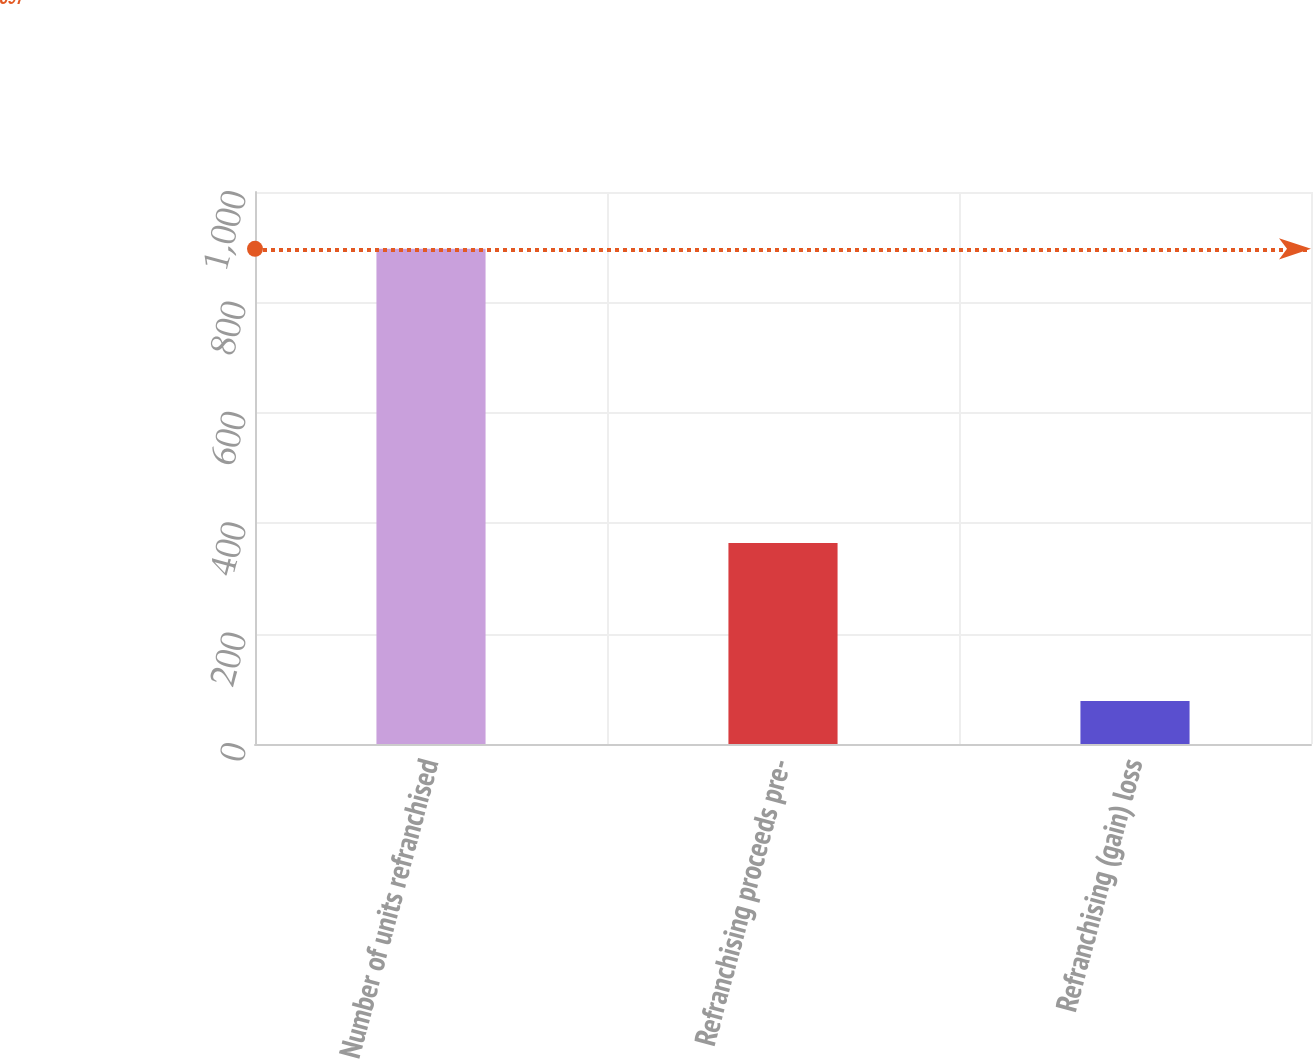Convert chart to OTSL. <chart><loc_0><loc_0><loc_500><loc_500><bar_chart><fcel>Number of units refranchised<fcel>Refranchising proceeds pre-<fcel>Refranchising (gain) loss<nl><fcel>897<fcel>364<fcel>78<nl></chart> 